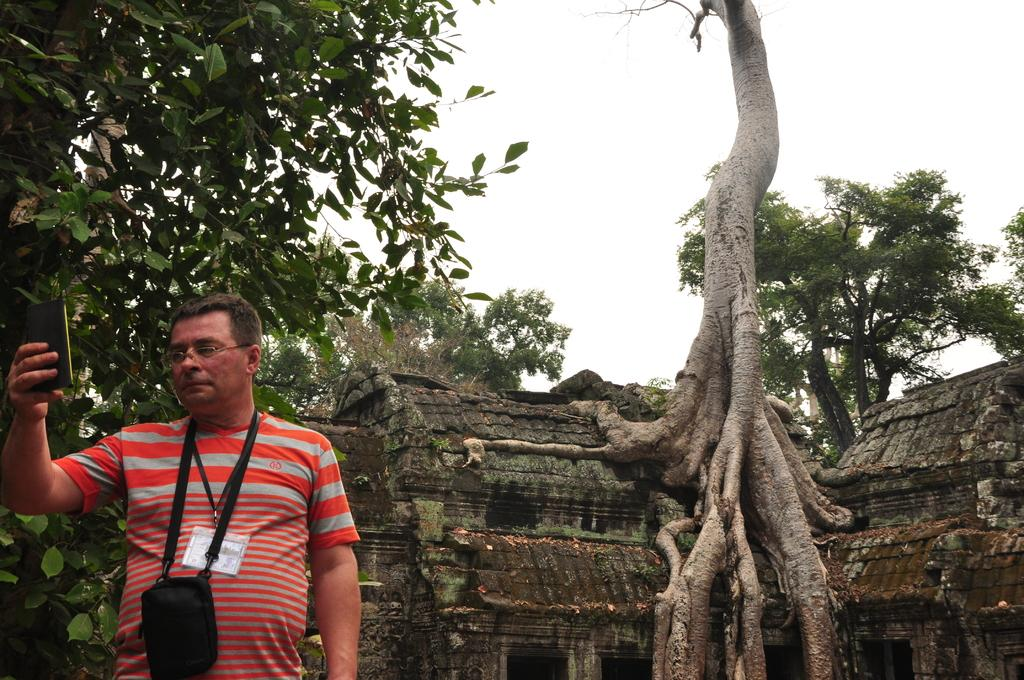What is the person in the image doing? The person is holding a mobile phone in his hand and looking at it. What might the person be doing with the mobile phone? The person might be checking messages, browsing the internet, or using an app on the mobile phone. What can be seen in the background behind the person? There are trees and an old house behind the person. What type of art is the person discussing with the person on the other end of the phone call? There is no indication in the image that the person is discussing art or any other topic with someone on the phone. 